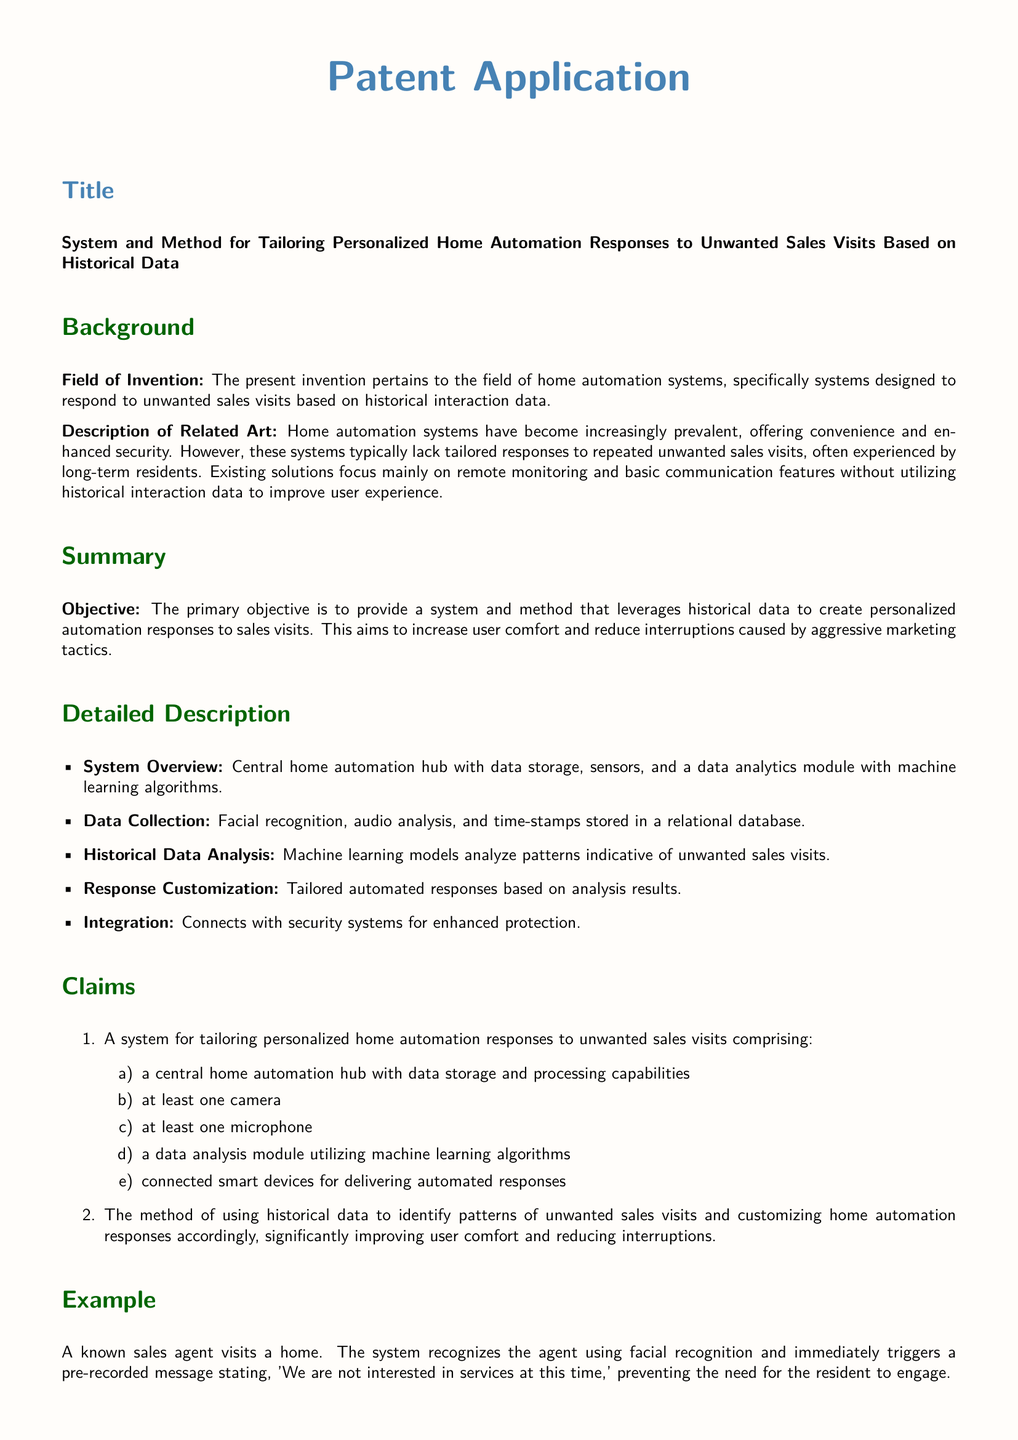What is the title of the patent application? The title of the patent application is stated at the beginning of the document.
Answer: System and Method for Tailoring Personalized Home Automation Responses to Unwanted Sales Visits Based on Historical Data What is the primary objective of the invention? The primary objective is mentioned in the summary section of the document.
Answer: To provide a system and method that leverages historical data to create personalized automation responses to sales visits What does the system utilize for data analysis? The document describes the components of the system in the detailed description section, specifying the analysis method.
Answer: Machine learning algorithms What type of data does the system collect? The detailed description outlines the types of data collected by the system.
Answer: Facial recognition, audio analysis, and time-stamps Which feature allows the system to respond to visitors? The claims section lists the components involved in the system, including automated response capabilities.
Answer: Connected smart devices for delivering automated responses What is an example of a response triggered by the system? The example section provides a specific scenario illustrating how the system operates.
Answer: 'We are not interested in services at this time' How does the system increase user comfort? The summary describes the benefits of the invention in relation to user experiences.
Answer: By tailoring automation responses to unwanted sales visits What type of system is this application focused on? The background section specifies the field that the invention pertains to.
Answer: Home automation systems What is one of the references cited in the document? The references section lists prior art relevant to the invention.
Answer: U.S. Patent No. 10,555,493 - Home automation system and method for identifying and responding to visitors 